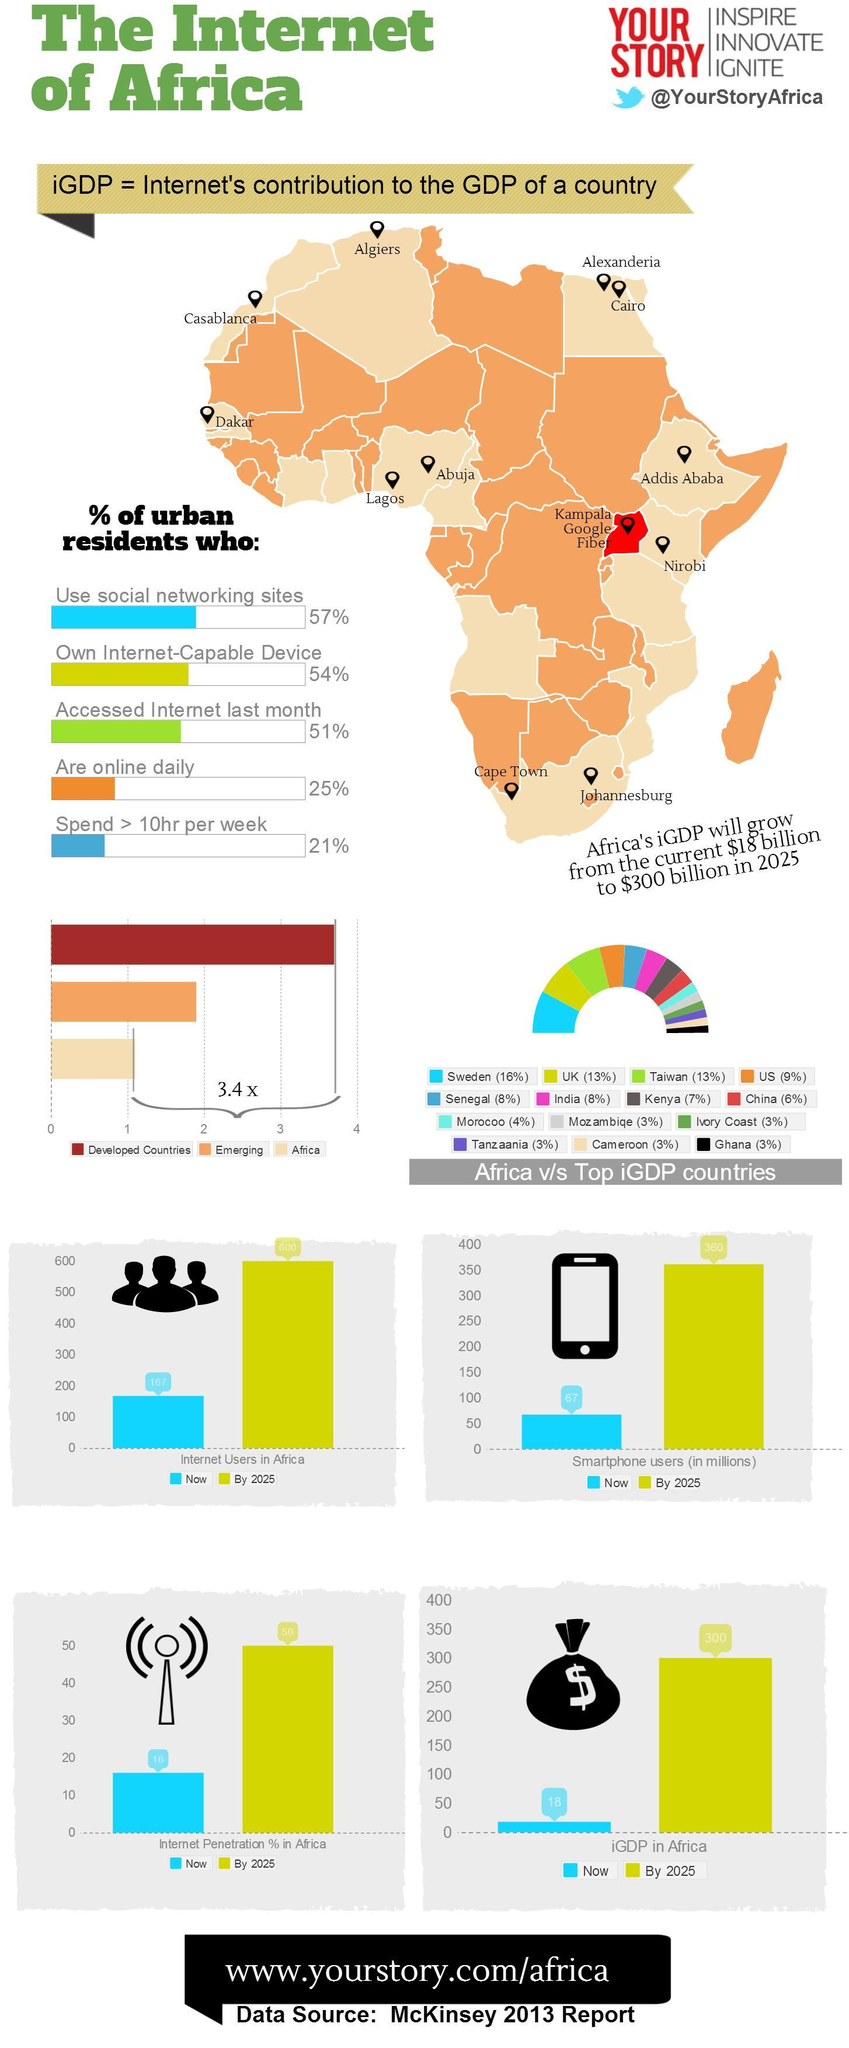What is the iGDP value for India?
Answer the question with a short phrase. 8% Which african country has same iGDP as India has? Senegal Which european country has second highest iGDP? UK In the map, what is written next to the area in red color? Kampala google fiber What percentage of african urbans do not have their own internet capable device? 46% By 2025, approximately how many million smartphone users will be there in Africa? 360 millions Which social media handle is given here - instagram, twitter or facebook? twitter 